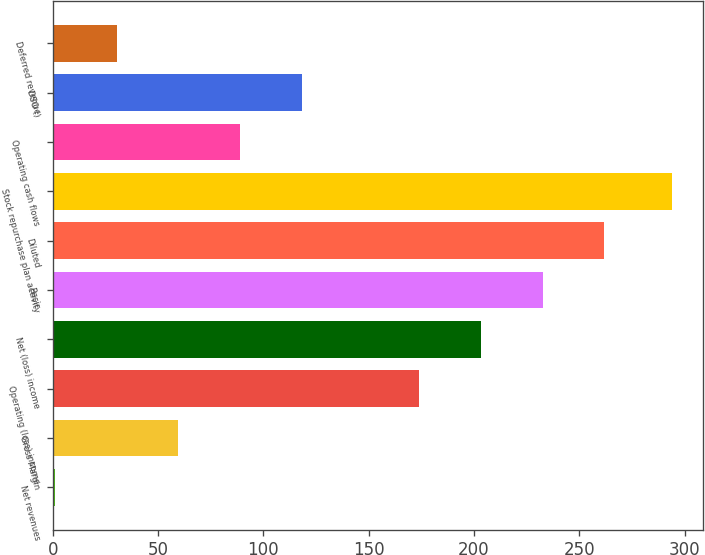<chart> <loc_0><loc_0><loc_500><loc_500><bar_chart><fcel>Net revenues<fcel>Gross Margin<fcel>Operating (loss) income<fcel>Net (loss) income<fcel>Basic<fcel>Diluted<fcel>Stock repurchase plan activity<fcel>Operating cash flows<fcel>DSO ()<fcel>Deferred revenue<nl><fcel>1<fcel>59.6<fcel>174<fcel>203.3<fcel>232.6<fcel>261.9<fcel>294<fcel>88.9<fcel>118.2<fcel>30.3<nl></chart> 